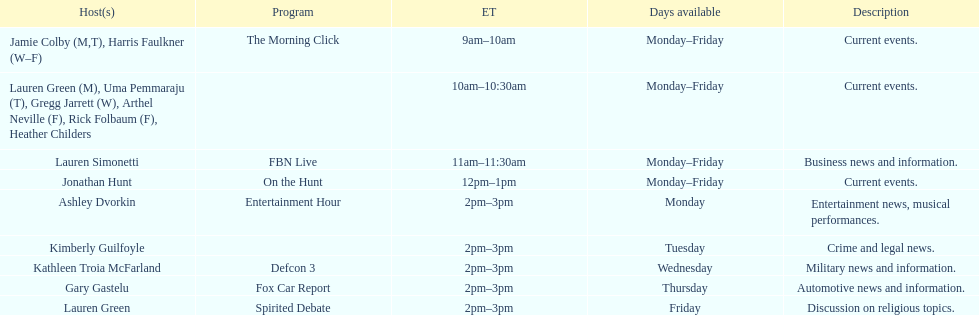How many days is fbn live available each week? 5. 